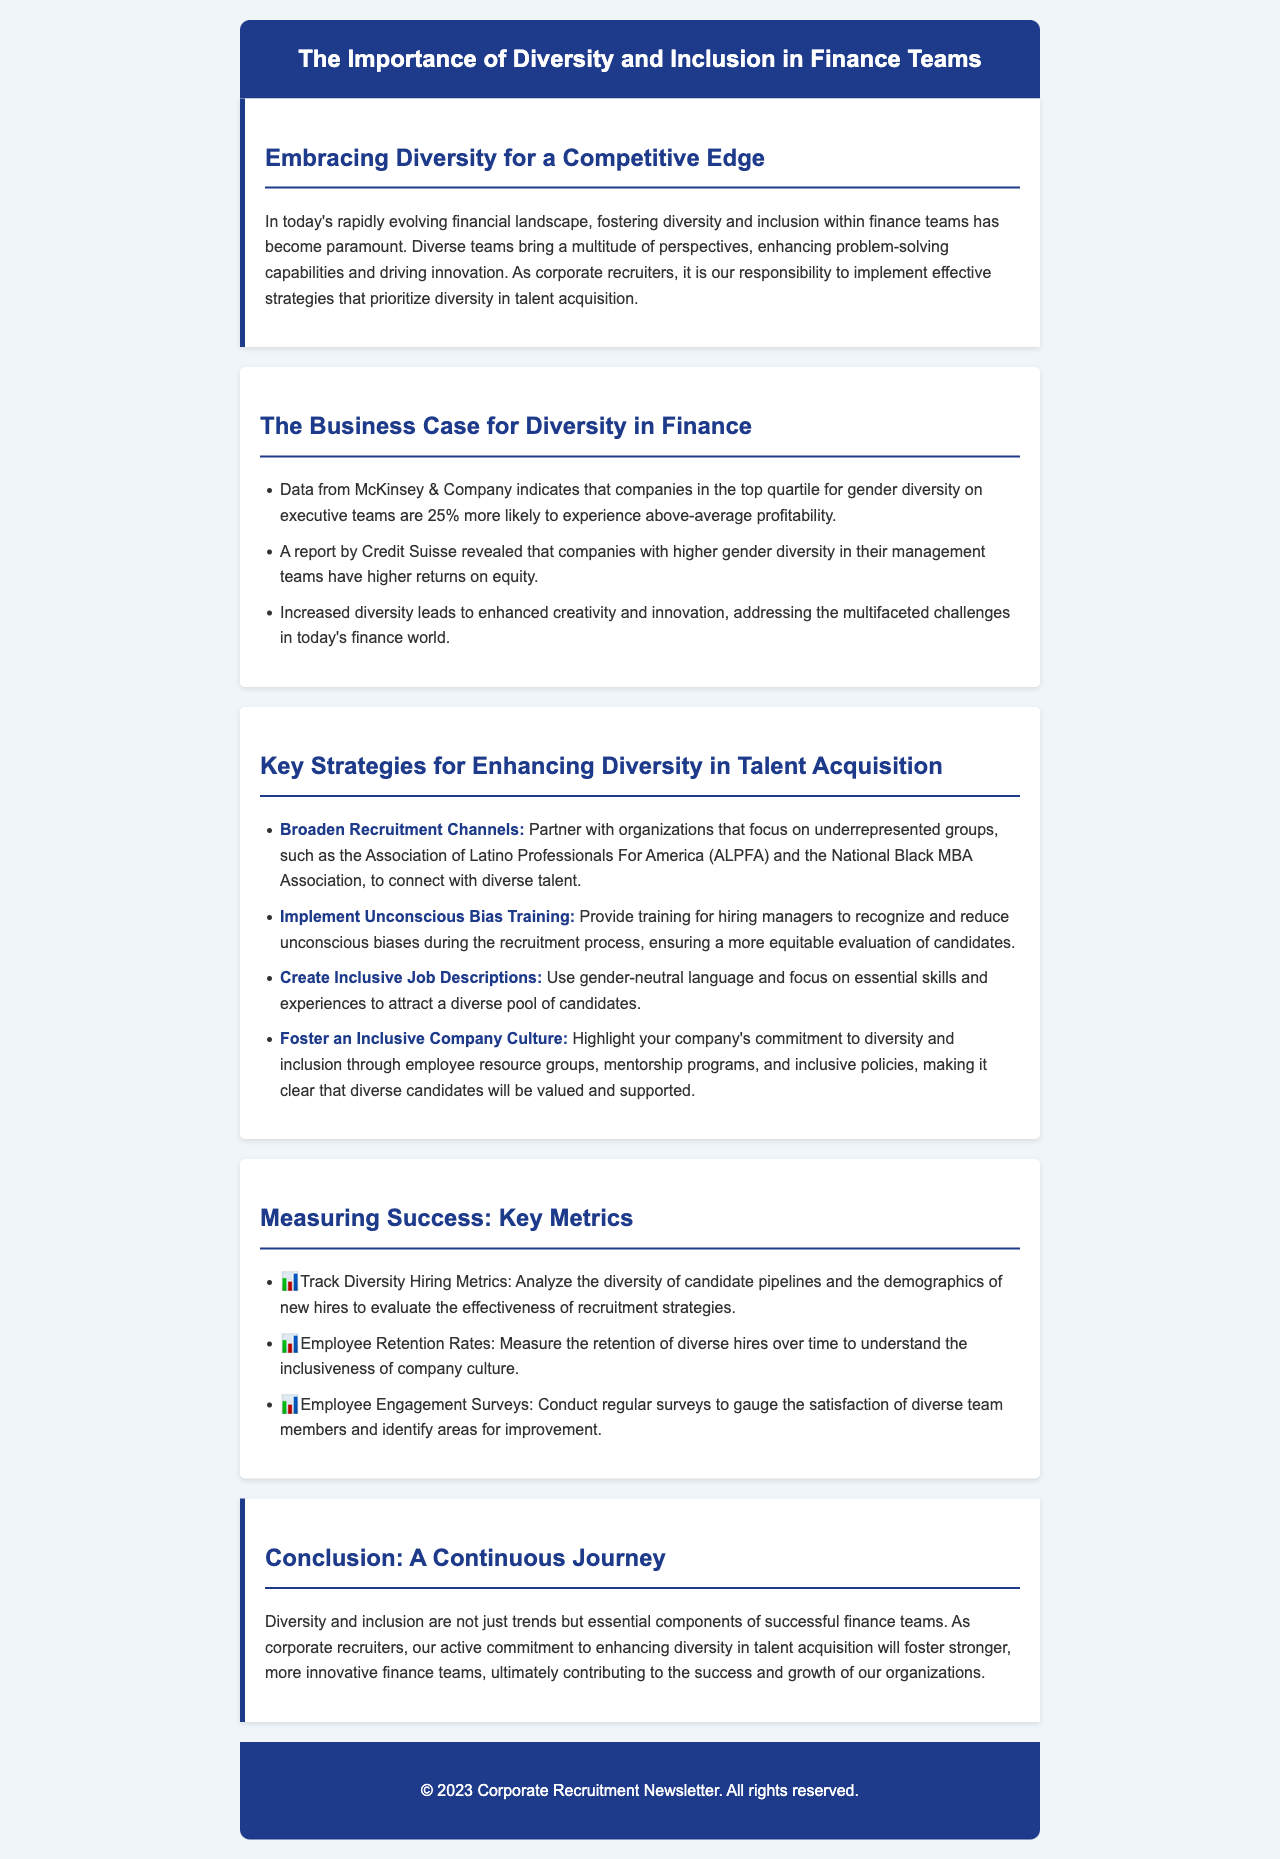What is the main focus of the newsletter? The main focus is on the importance of diversity and inclusion in finance teams and strategies for recruiters.
Answer: Diversity and inclusion in finance teams What percentage more likely are companies with gender diversity on executive teams to experience above-average profitability? According to data from McKinsey & Company, companies in the top quartile for gender diversity are 25% more likely to experience above-average profitability.
Answer: 25% Which organization is mentioned as a partner for connecting with underrepresented groups? The newsletter mentions the Association of Latino Professionals For America as a partner organization.
Answer: Association of Latino Professionals For America What training should be implemented to help reduce biases? The newsletter recommends implementing unconscious bias training for hiring managers.
Answer: Unconscious bias training What is one key metric to measure the effectiveness of recruitment strategies? One key metric is to track diversity hiring metrics.
Answer: Diversity hiring metrics What is the impact of higher gender diversity on returns? A report by Credit Suisse revealed that companies with higher gender diversity in management have higher returns on equity.
Answer: Higher returns on equity What is emphasized as essential for retention of diverse hires? The newsletter emphasizes measuring employee retention rates to understand the inclusiveness of company culture.
Answer: Employee retention rates What is a stated benefit of diverse teams in problem-solving? Diverse teams enhance problem-solving capabilities by bringing multiple perspectives.
Answer: Multiple perspectives What type of language should be used in job descriptions? Job descriptions should use gender-neutral language.
Answer: Gender-neutral language 